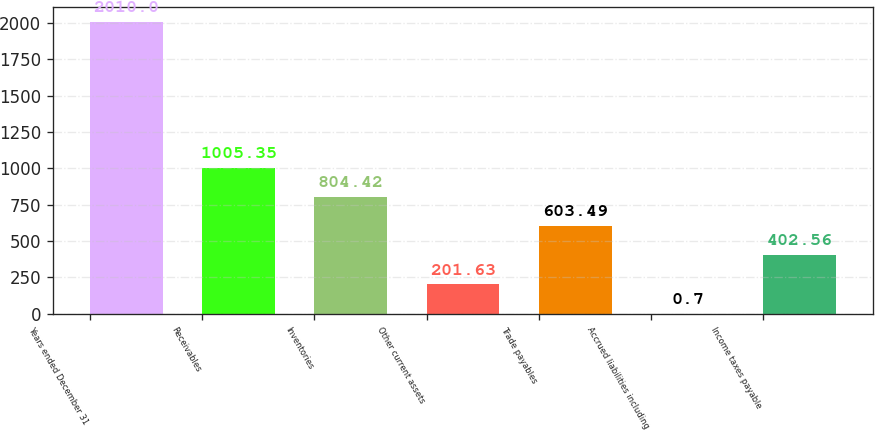Convert chart. <chart><loc_0><loc_0><loc_500><loc_500><bar_chart><fcel>Years ended December 31<fcel>Receivables<fcel>Inventories<fcel>Other current assets<fcel>Trade payables<fcel>Accrued liabilities including<fcel>Income taxes payable<nl><fcel>2010<fcel>1005.35<fcel>804.42<fcel>201.63<fcel>603.49<fcel>0.7<fcel>402.56<nl></chart> 